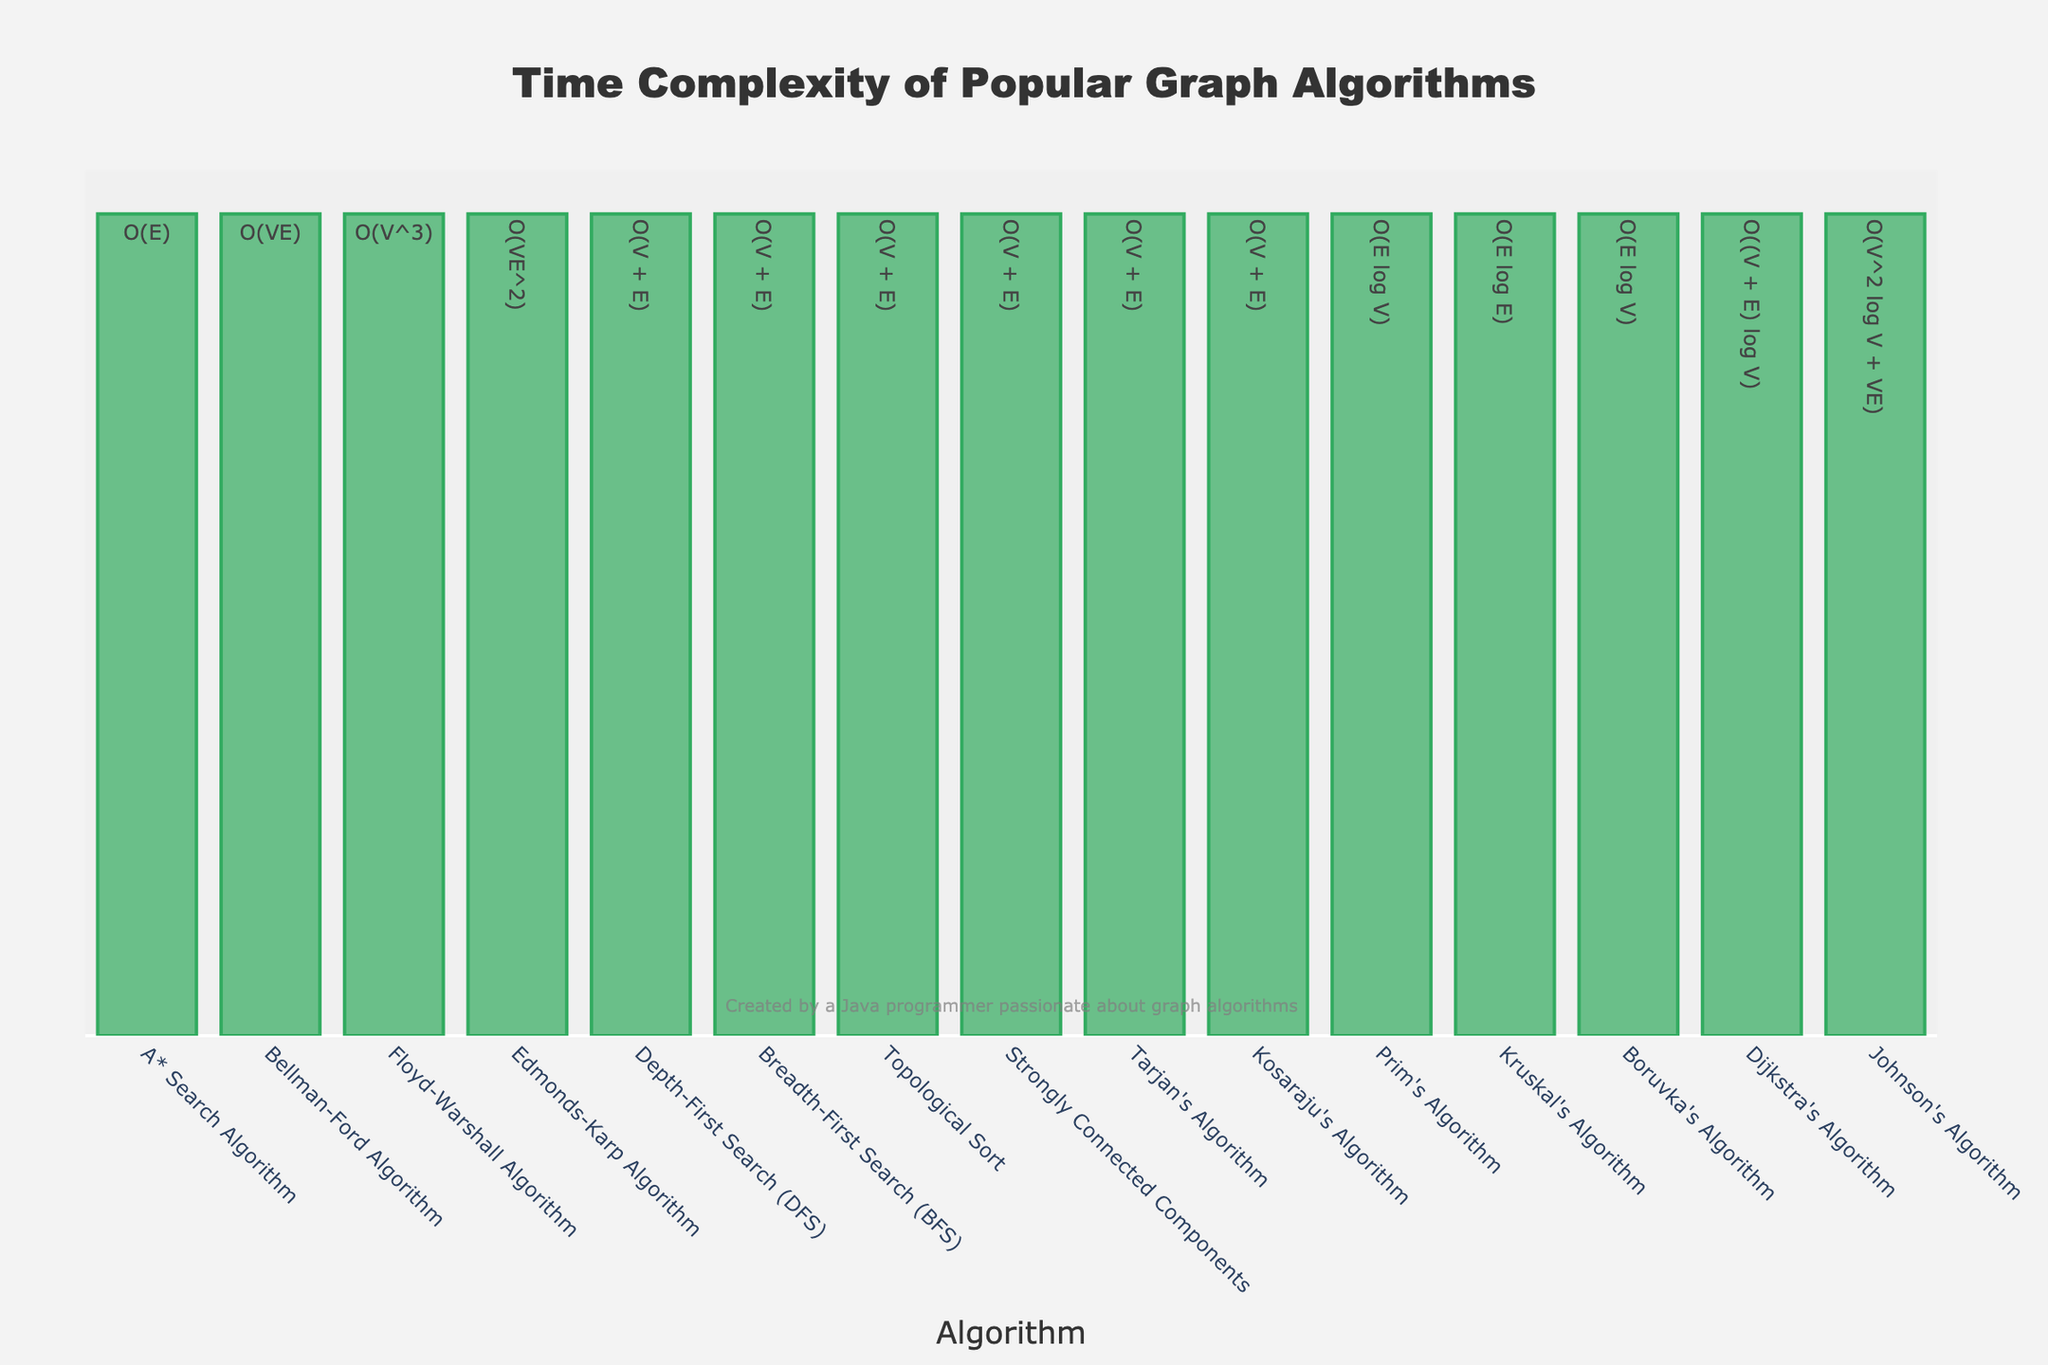Which algorithm has the highest time complexity? The algorithm with the highest time complexity has the tallest bar on the chart.
Answer: Floyd-Warshall Algorithm Which two algorithms have a time complexity of O(V + E)? Find the algorithms that have the same time complexity labeled "O(V + E)" next to their bars.
Answer: Depth-First Search (DFS), Breadth-First Search (BFS), Topological Sort, Strongly Connected Components, Tarjan's Algorithm, Kosaraju's Algorithm Which algorithm is listed with the time complexity O(E log E)? Look for the algorithm with a time complexity labeled "O(E log E)" next to its bar.
Answer: Kruskal's Algorithm What is the difference in time complexity between Dijkstra's Algorithm and the Floyd-Warshall Algorithm? Compare the complexities of Dijkstra's Algorithm "O((V + E) log V)" and Floyd-Warshall Algorithm "O(V^3)", then calculate the difference based on their order of magnitude.
Answer: O(V^3 - (V + E) log V) Which algorithms have a time complexity similar to Prim's Algorithm? Find algorithms with similar time complexities, labeled close to "O(E log V)" which is Prim's Algorithm's complexity.
Answer: Boruvka's Algorithm How many algorithms have a linear time complexity in relation to the number of vertices and edges? Count the number of algorithms with time complexities labeled "O(V + E)".
Answer: 6 What is the visual attribute of the bar representing Tarjan's Algorithm? Describe the appearance of the bar based on its position and color on the chart.
Answer: Positioned near the algorithms with "O(V + E)" complexity, green color Which algorithm appears to be most efficient based on the time complexity? The most efficient algorithm will have the smallest order of complexity, indicated by the shortest bar.
Answer: Depth-First Search (DFS), Breadth-First Search (BFS), Topological Sort, Strongly Connected Components, Tarjan's Algorithm, Kosaraju's Algorithm Can you list algorithms with logarithmic factors in their time complexity? Identify the algorithms whose complexities include log terms, such as "log V", "log E".
Answer: Dijkstra's Algorithm, Prim's Algorithm, Boruvka's Algorithm, Kruskal's Algorithm 